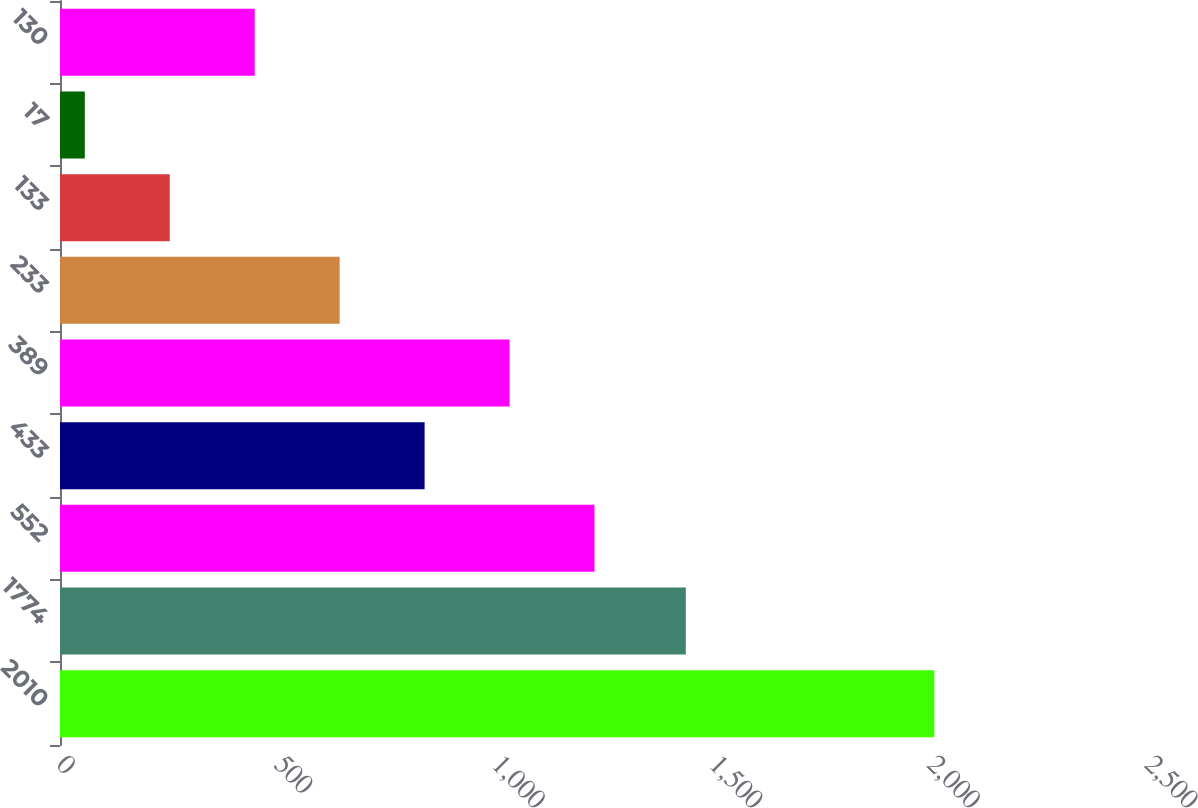<chart> <loc_0><loc_0><loc_500><loc_500><bar_chart><fcel>2010<fcel>1774<fcel>552<fcel>433<fcel>389<fcel>233<fcel>133<fcel>17<fcel>130<nl><fcel>2009<fcel>1438<fcel>1228.2<fcel>837.8<fcel>1033<fcel>642.6<fcel>252.2<fcel>57<fcel>447.4<nl></chart> 